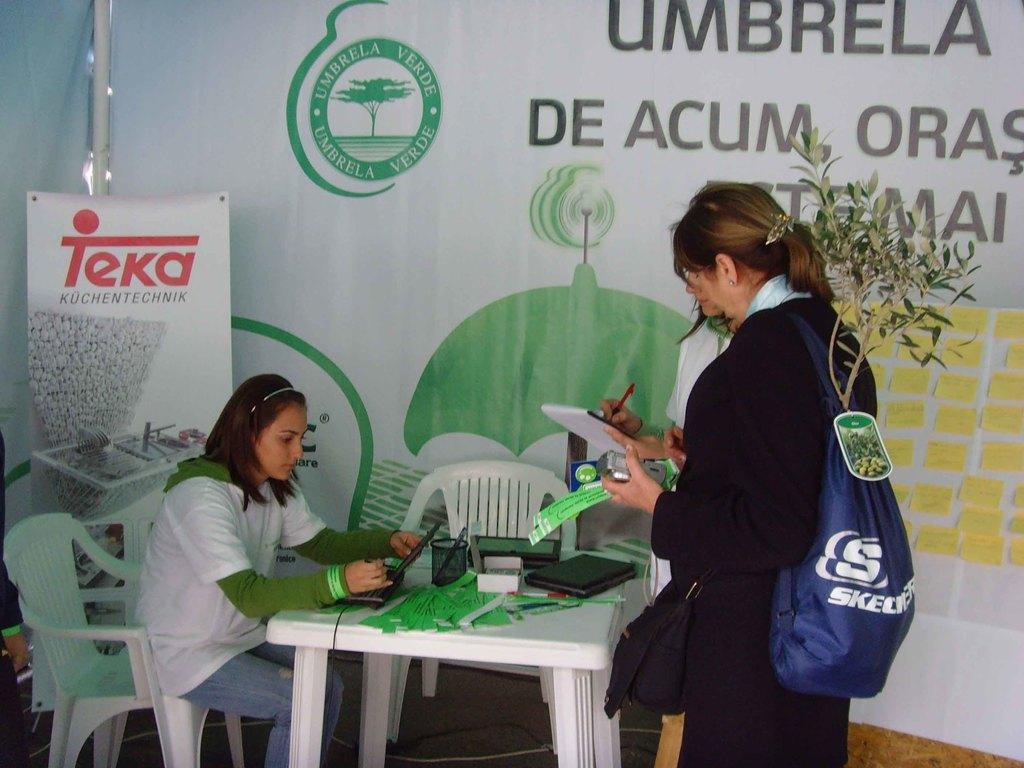In one or two sentences, can you explain what this image depicts? This picture shows there is a woman sitting in the chair in front of a table on which some accessories were placed. There are two members standing in front of the table, holding a bag on the shoulder. In the background there is a poster. 